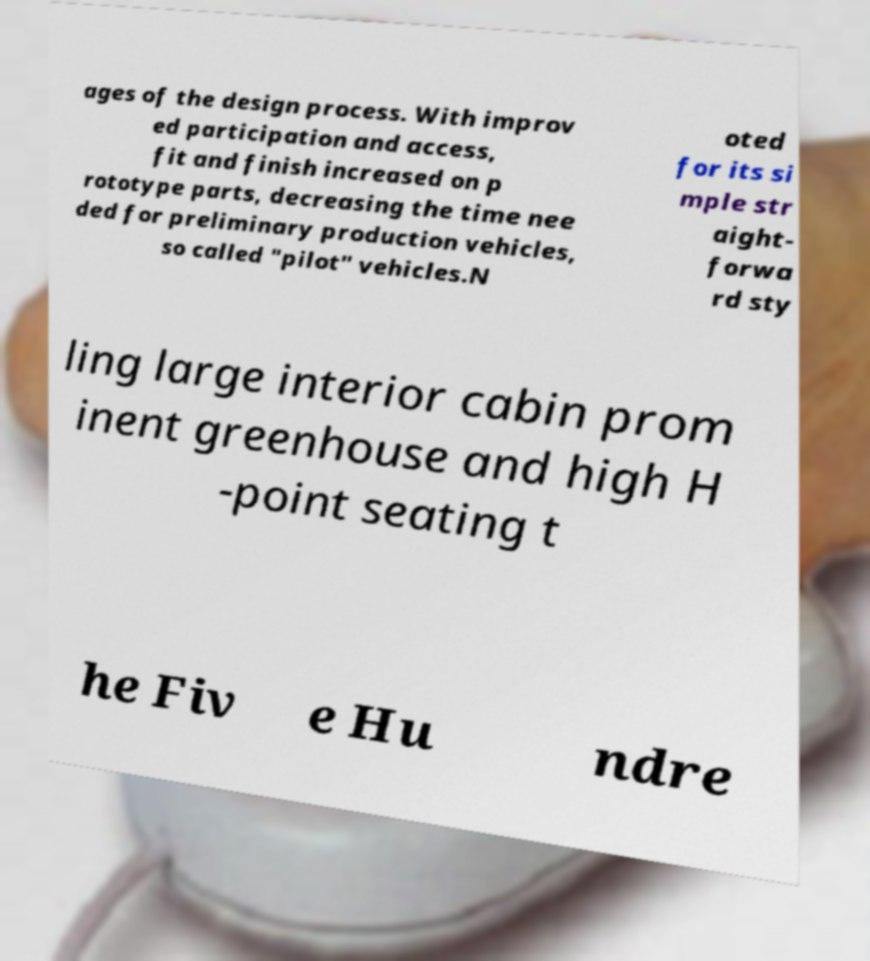Please read and relay the text visible in this image. What does it say? ages of the design process. With improv ed participation and access, fit and finish increased on p rototype parts, decreasing the time nee ded for preliminary production vehicles, so called "pilot" vehicles.N oted for its si mple str aight- forwa rd sty ling large interior cabin prom inent greenhouse and high H -point seating t he Fiv e Hu ndre 